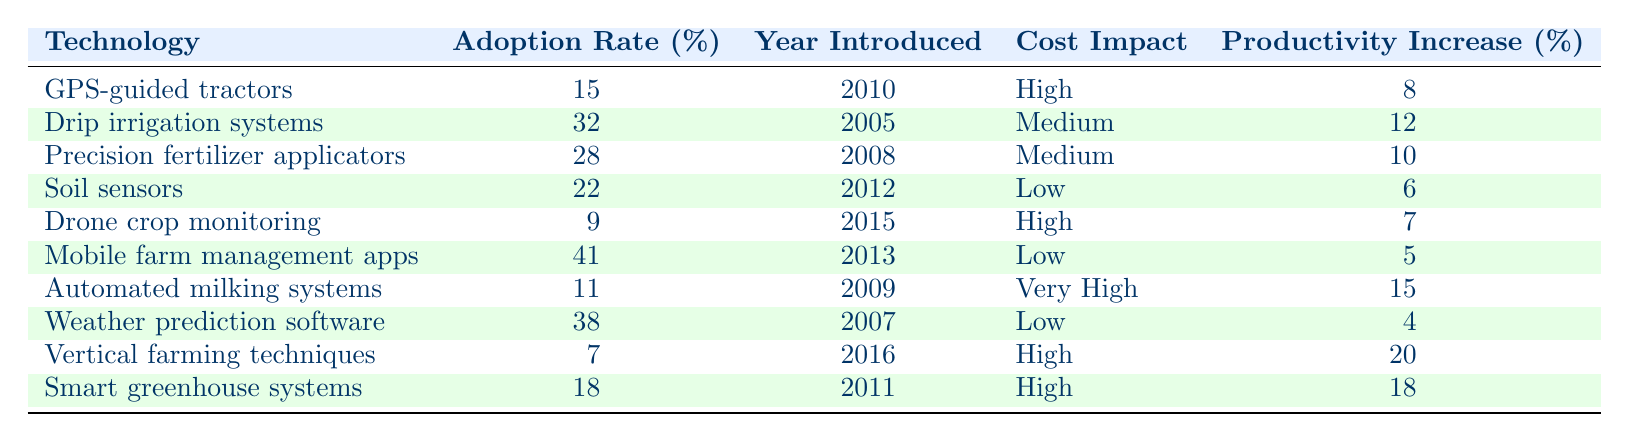What is the adoption rate of drip irrigation systems? The table states that the adoption rate for drip irrigation systems is 32%.
Answer: 32% Which technology was introduced in the year 2005? The table shows that drip irrigation systems were introduced in 2005.
Answer: Drip irrigation systems What is the cost impact of automated milking systems? According to the table, automated milking systems have a very high cost impact.
Answer: Very High What is the highest productivity increase percentage among the listed technologies? The table indicates that vertical farming techniques have the highest productivity increase percentage at 20%.
Answer: 20% How many technologies have an adoption rate above 30%? The table lists three technologies with adoption rates above 30%: drip irrigation systems (32%), precision fertilizer applicators (28%), and mobile farm management apps (41%). So the answer is two technologies.
Answer: 2 Is the adoption rate of drone crop monitoring higher than that of GPS-guided tractors? The adoption rate of drone crop monitoring is 9%, while GPS-guided tractors have an adoption rate of 15%. Thus, drone crop monitoring has a lower adoption rate.
Answer: No What is the average adoption rate of technologies introduced before 2010? Technologies introduced before 2010 are: drip irrigation systems (32%), precision fertilizer applicators (28%), automated milking systems (11%), and weather prediction software (38%). The sum of these rates is 32 + 28 + 11 + 38 = 109, and there are 4 technologies. Therefore, the average is 109/4 = 27.25%.
Answer: 27.25% Which technology has the lowest adoption rate and what is it? The table shows that vertical farming techniques have the lowest adoption rate at 7%.
Answer: Vertical farming techniques, 7% What is the difference in adoption rates between mobile farm management apps and soil sensors? Mobile farm management apps have an adoption rate of 41%, while soil sensors have an adoption rate of 22%. The difference is 41 - 22 = 19%.
Answer: 19% What percentage of technologies reported a low cost impact? The table lists four technologies with a low cost impact: soil sensors, mobile farm management apps, weather prediction software, and smart greenhouse systems. There are 10 technologies in total. Therefore, the percentage is (4/10) * 100 = 40%.
Answer: 40% Which technology has the highest productivity increase and what is the value? Vertical farming techniques have the highest productivity increase percentage at 20%.
Answer: Vertical farming techniques, 20% 